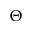<formula> <loc_0><loc_0><loc_500><loc_500>\Theta</formula> 